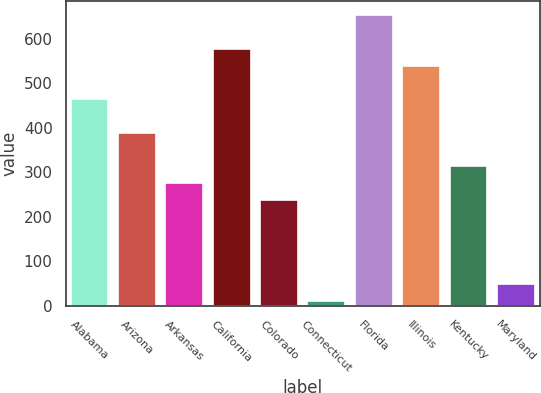Convert chart. <chart><loc_0><loc_0><loc_500><loc_500><bar_chart><fcel>Alabama<fcel>Arizona<fcel>Arkansas<fcel>California<fcel>Colorado<fcel>Connecticut<fcel>Florida<fcel>Illinois<fcel>Kentucky<fcel>Maryland<nl><fcel>464.4<fcel>389<fcel>275.9<fcel>577.5<fcel>238.2<fcel>12<fcel>652.9<fcel>539.8<fcel>313.6<fcel>49.7<nl></chart> 